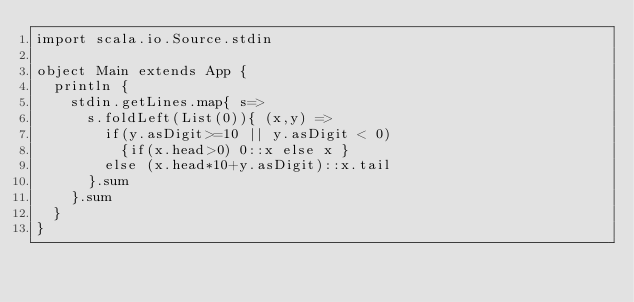Convert code to text. <code><loc_0><loc_0><loc_500><loc_500><_Scala_>import scala.io.Source.stdin

object Main extends App {
  println {
    stdin.getLines.map{ s=>
      s.foldLeft(List(0)){ (x,y) =>
        if(y.asDigit>=10 || y.asDigit < 0)
          {if(x.head>0) 0::x else x }
        else (x.head*10+y.asDigit)::x.tail
      }.sum
    }.sum
  }
}</code> 